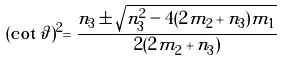<formula> <loc_0><loc_0><loc_500><loc_500>( \cot \vartheta ) ^ { 2 } = \frac { n _ { 3 } \pm \sqrt { n _ { 3 } ^ { 2 } - 4 ( 2 m _ { 2 } + n _ { 3 } ) m _ { 1 } } } { 2 ( 2 m _ { 2 } + n _ { 3 } ) }</formula> 